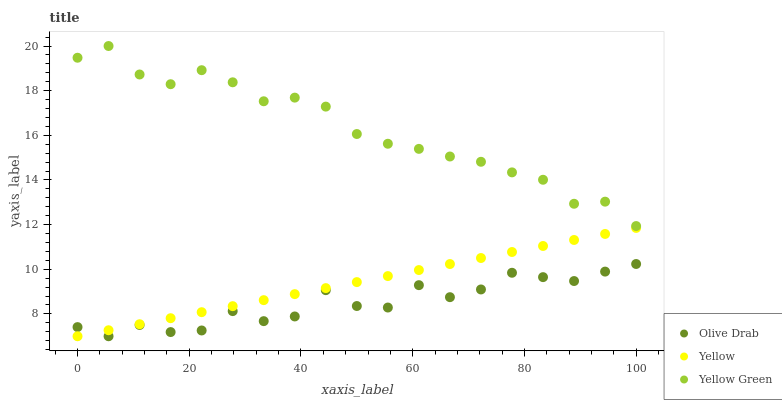Does Olive Drab have the minimum area under the curve?
Answer yes or no. Yes. Does Yellow Green have the maximum area under the curve?
Answer yes or no. Yes. Does Yellow Green have the minimum area under the curve?
Answer yes or no. No. Does Olive Drab have the maximum area under the curve?
Answer yes or no. No. Is Yellow the smoothest?
Answer yes or no. Yes. Is Olive Drab the roughest?
Answer yes or no. Yes. Is Yellow Green the smoothest?
Answer yes or no. No. Is Yellow Green the roughest?
Answer yes or no. No. Does Yellow have the lowest value?
Answer yes or no. Yes. Does Yellow Green have the lowest value?
Answer yes or no. No. Does Yellow Green have the highest value?
Answer yes or no. Yes. Does Olive Drab have the highest value?
Answer yes or no. No. Is Olive Drab less than Yellow Green?
Answer yes or no. Yes. Is Yellow Green greater than Yellow?
Answer yes or no. Yes. Does Yellow intersect Olive Drab?
Answer yes or no. Yes. Is Yellow less than Olive Drab?
Answer yes or no. No. Is Yellow greater than Olive Drab?
Answer yes or no. No. Does Olive Drab intersect Yellow Green?
Answer yes or no. No. 